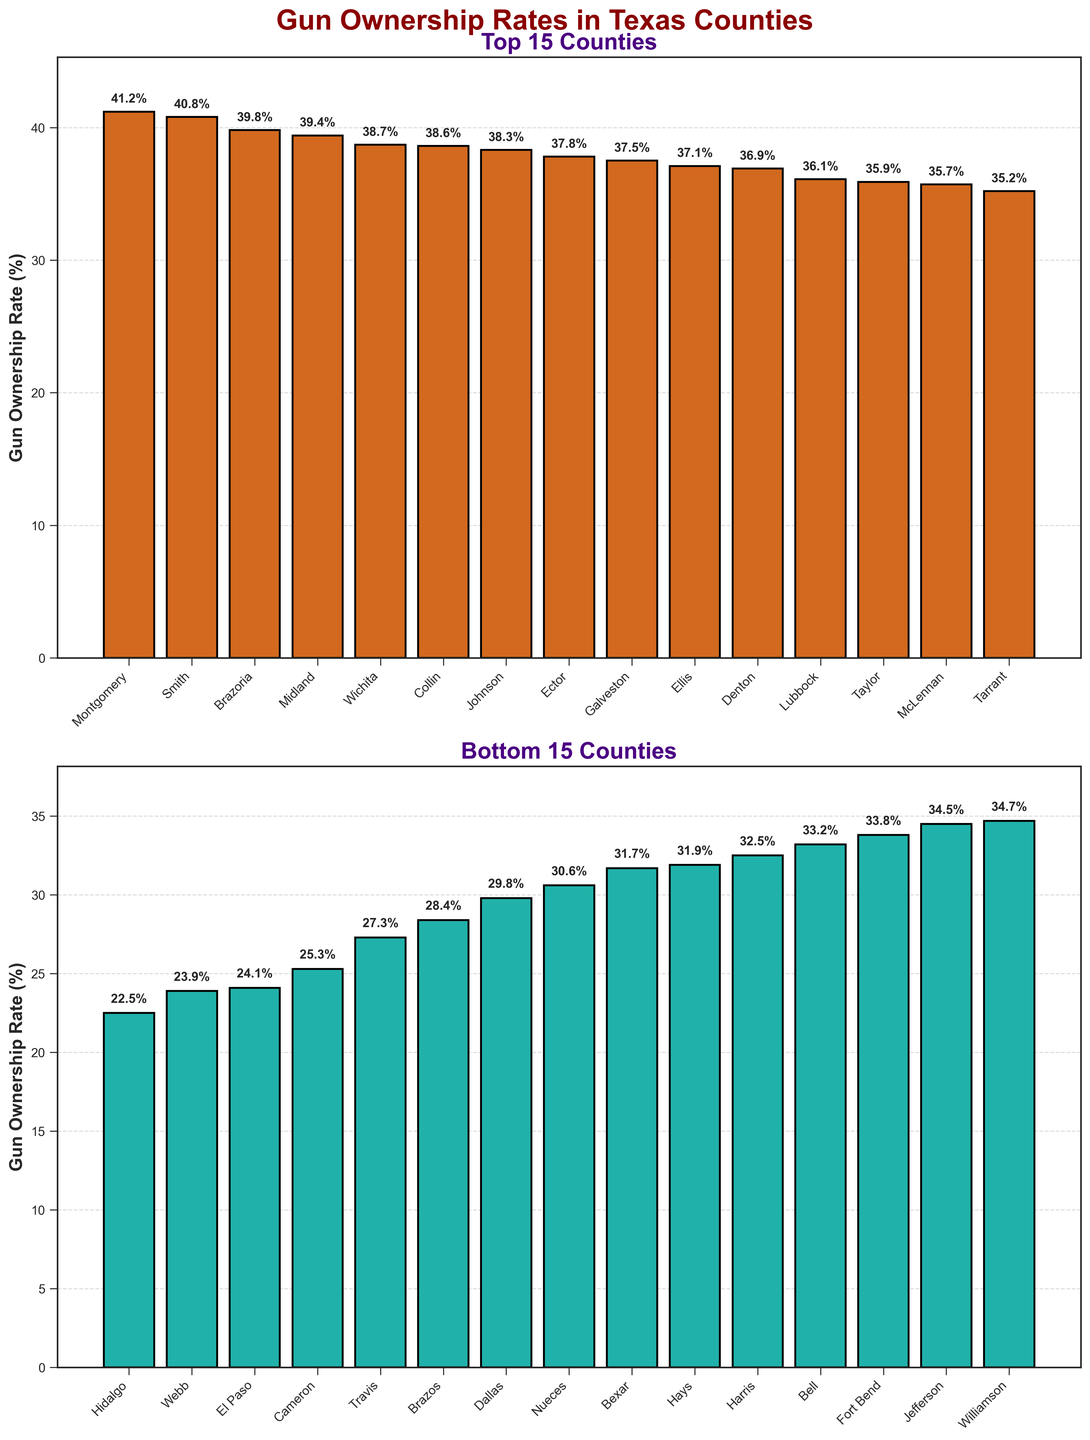Which county has the highest gun ownership rate in the Top 15 Counties subplot? In the Top 15 Counties subplot, the tallest bar represents Montgomery County with a gun ownership rate of 41.2%.
Answer: Montgomery What is the difference in gun ownership rates between Galveston and Taylor counties in the Top 15 Counties subplot? In the Top 15 Counties subplot, Galveston has a gun ownership rate of 37.5% and Taylor has 35.9%. The difference is 37.5% - 35.9% = 1.6%.
Answer: 1.6% Which county has the lowest gun ownership rate in the Bottom 15 Counties subplot? In the Bottom 15 Counties subplot, the shortest bar represents Hidalgo County with a gun ownership rate of 22.5%.
Answer: Hidalgo How many counties in the Top 15 Counties subplot have a gun ownership rate above 38%? In the Top 15 Counties subplot, the counties with a gun ownership rate above 38% are Collin (38.6%), Brazoria (39.8%), Johnson (38.3%), Midland (39.4%), Wichita (38.7%), Montgomery (41.2%), and Smith (40.8%). Counting these, we get 7 counties.
Answer: 7 Compare the bar heights of Travis and Cameron counties. Which has a higher gun ownership rate and by how much? In the figure, Travis has a gun ownership rate of 27.3% and Cameron has 25.3%. The difference is 27.3% - 25.3% = 2%. Therefore, Travis has a higher rate by 2%.
Answer: Travis by 2% What is the average gun ownership rate for the Bottom 15 Counties? Add up the gun ownership rates for the Bottom 15 Counties: 29.8 + 31.7 + 27.3 + 24.1 + 22.5 + 28.4 + 25.3 + 23.9 + 31.9 + 30.6 + 33.2 + 34.5 = 366.2. Divide by the number of counties (12, because 15 counties shown in the Top 15 plot are distinct from the Bottom 15): 366.2 / 12 = 30.52%.
Answer: 30.52% Which county in the Bottom 15 Counties subplot has the closest gun ownership rate to the overall average of 30.52%? In the Bottom 15 Counties subplot, the county whose gun ownership rate is closest to 30.52% is Dallas with a rate of 29.8%.
Answer: Dallas 